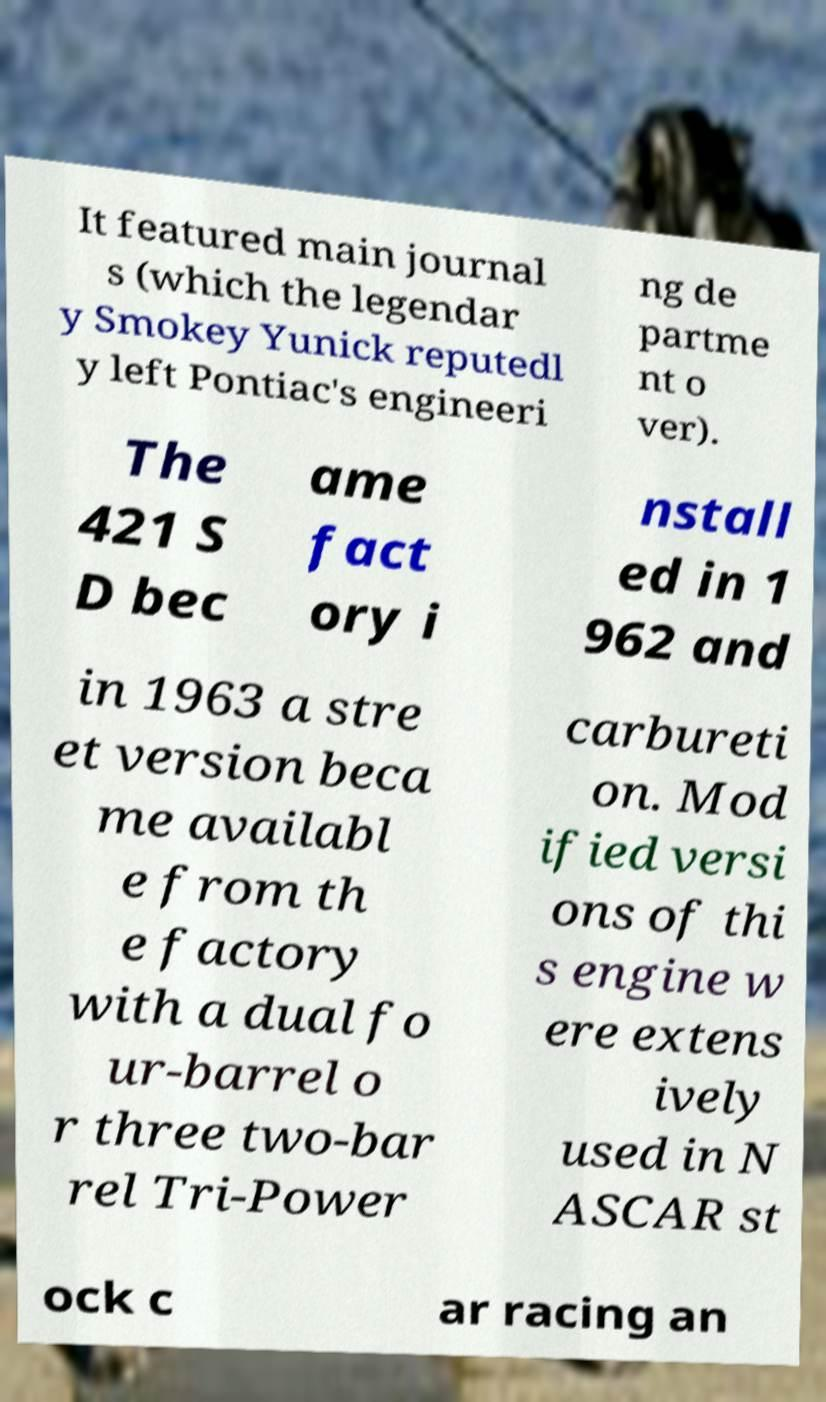There's text embedded in this image that I need extracted. Can you transcribe it verbatim? It featured main journal s (which the legendar y Smokey Yunick reputedl y left Pontiac's engineeri ng de partme nt o ver). The 421 S D bec ame fact ory i nstall ed in 1 962 and in 1963 a stre et version beca me availabl e from th e factory with a dual fo ur-barrel o r three two-bar rel Tri-Power carbureti on. Mod ified versi ons of thi s engine w ere extens ively used in N ASCAR st ock c ar racing an 